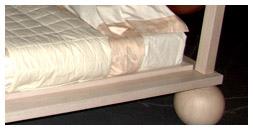What shape is at the bottom of the pole?
Concise answer only. Round. What furniture style is this?
Concise answer only. Modern. Is the bed made?
Keep it brief. Yes. 